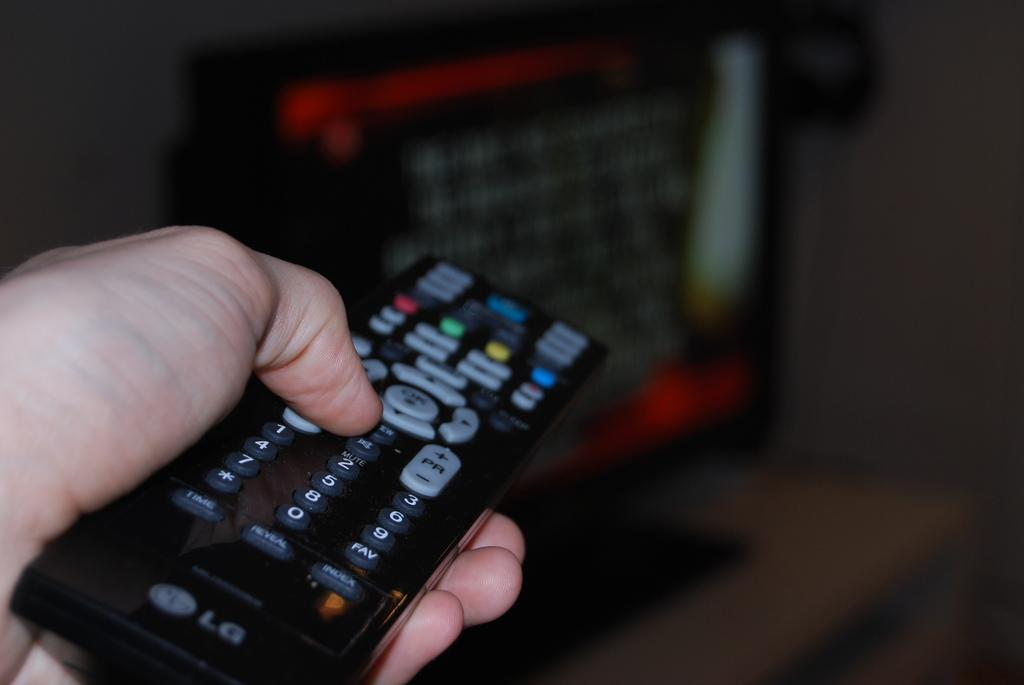Provide a one-sentence caption for the provided image. A hand holds an LG remote with a full 10 key numeric pad, a button that says PFI, and others. 